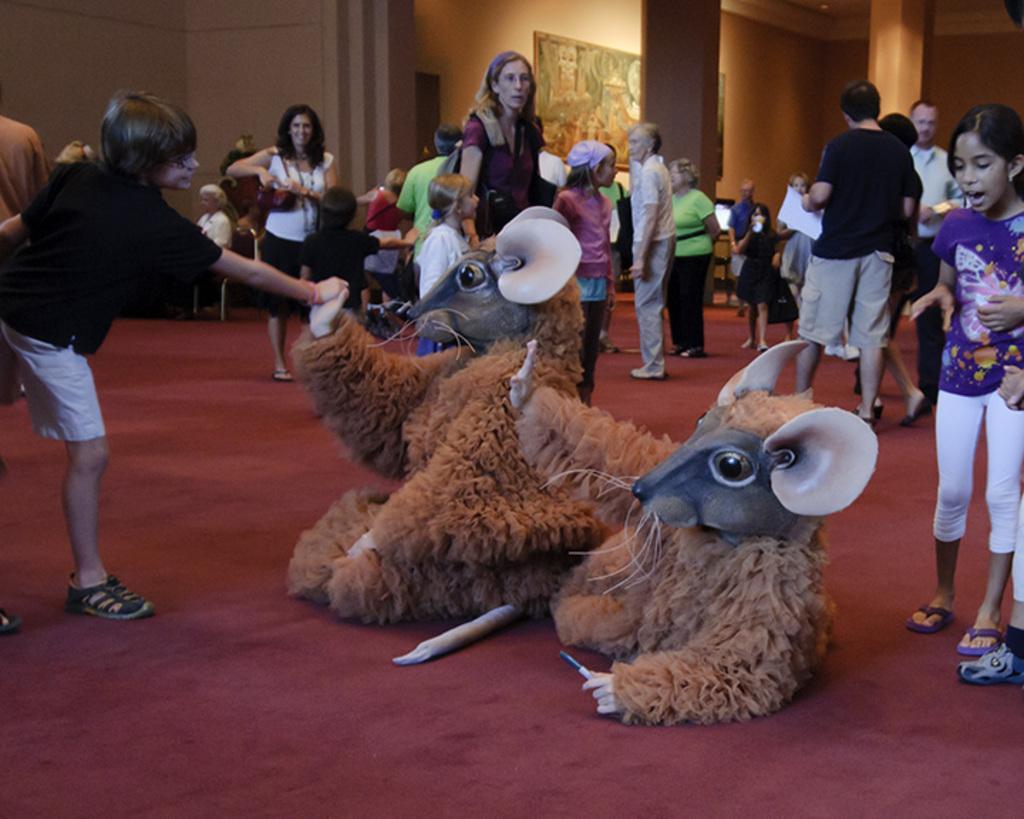Please provide a concise description of this image. In this image we can see people sitting on the chairs and some are standing on the floor. In the center of the image we can see persons wearing costumes and lying on the floor. In the background there are walls and a wall hanging. 